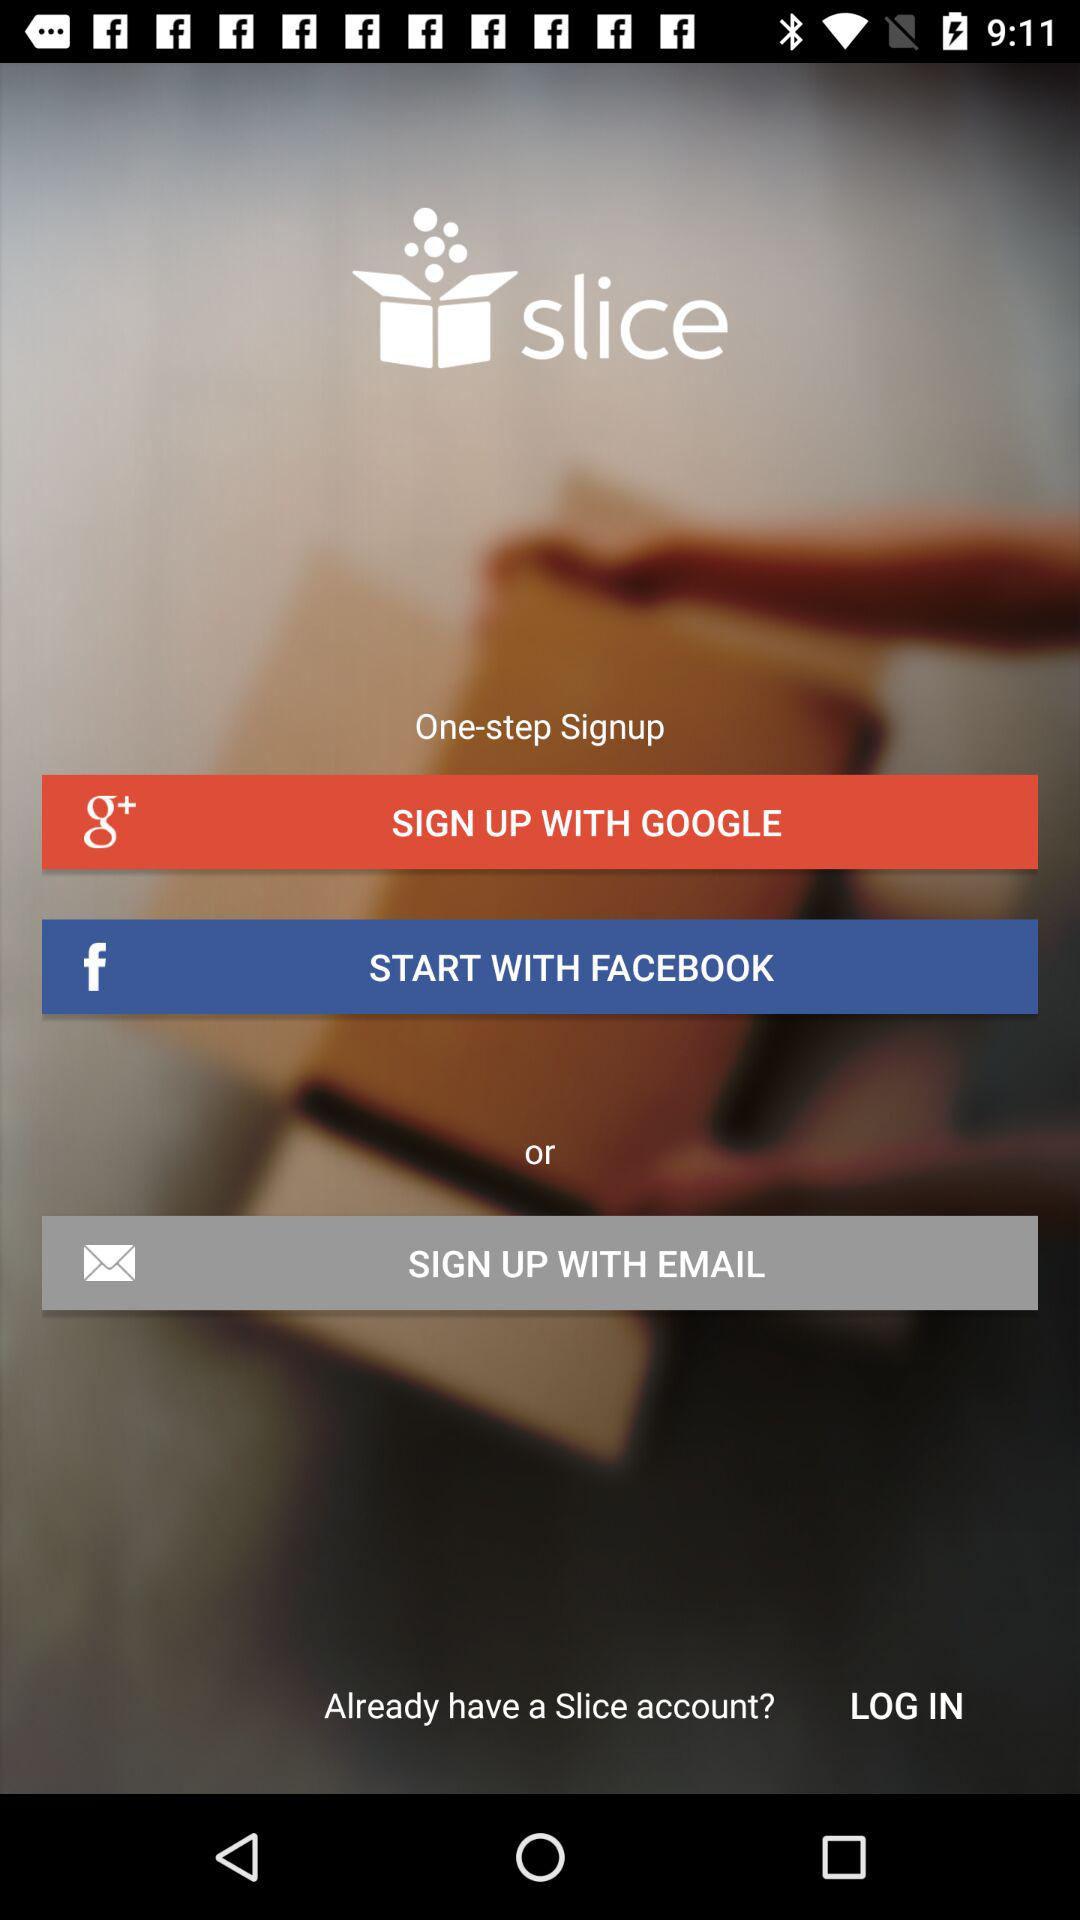What account can be used to sign up for the application? The accounts that can be used to sign up for the application are "GOOGLE", "FACEBOOK" and "EMAIL". 